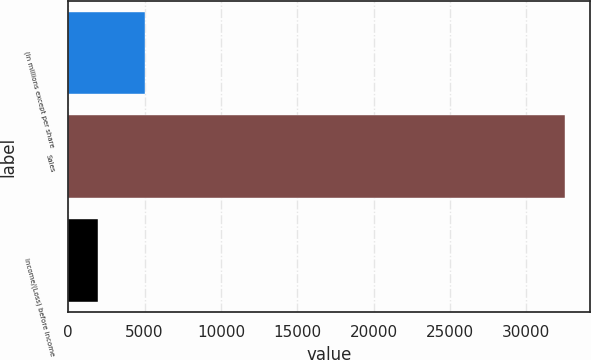Convert chart. <chart><loc_0><loc_0><loc_500><loc_500><bar_chart><fcel>(In millions except per share<fcel>Sales<fcel>Income/(Loss) before income<nl><fcel>5031.2<fcel>32564<fcel>1972<nl></chart> 